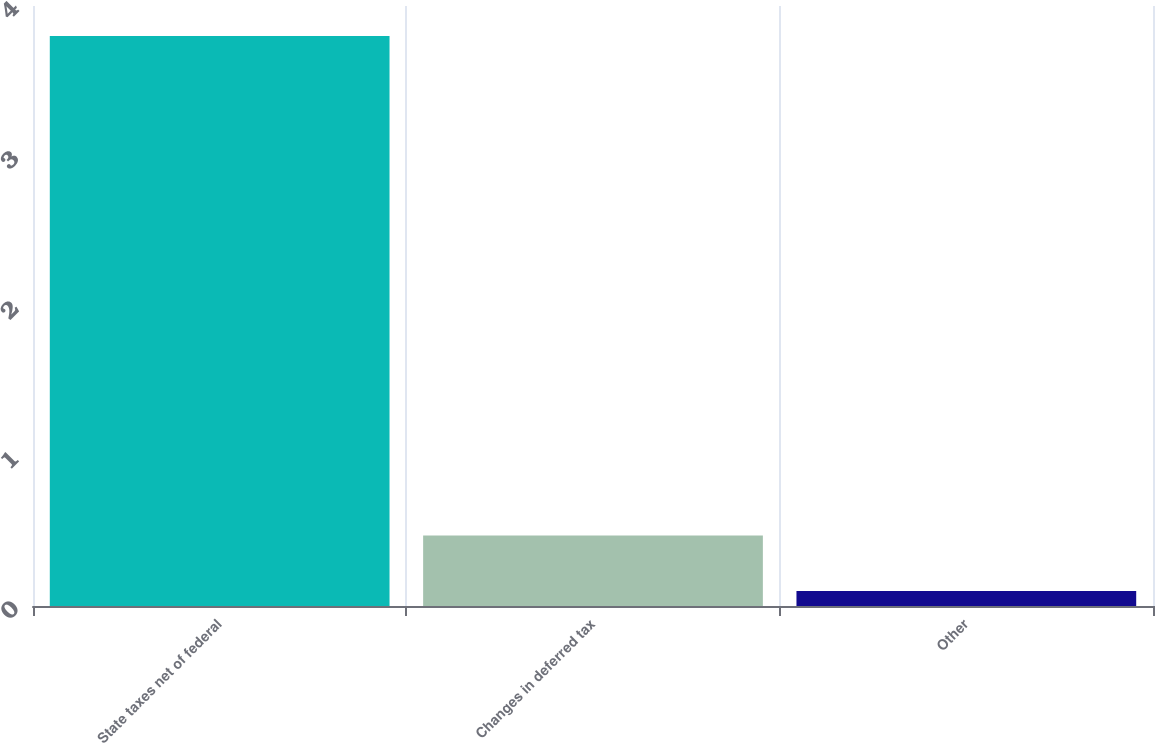<chart> <loc_0><loc_0><loc_500><loc_500><bar_chart><fcel>State taxes net of federal<fcel>Changes in deferred tax<fcel>Other<nl><fcel>3.8<fcel>0.47<fcel>0.1<nl></chart> 